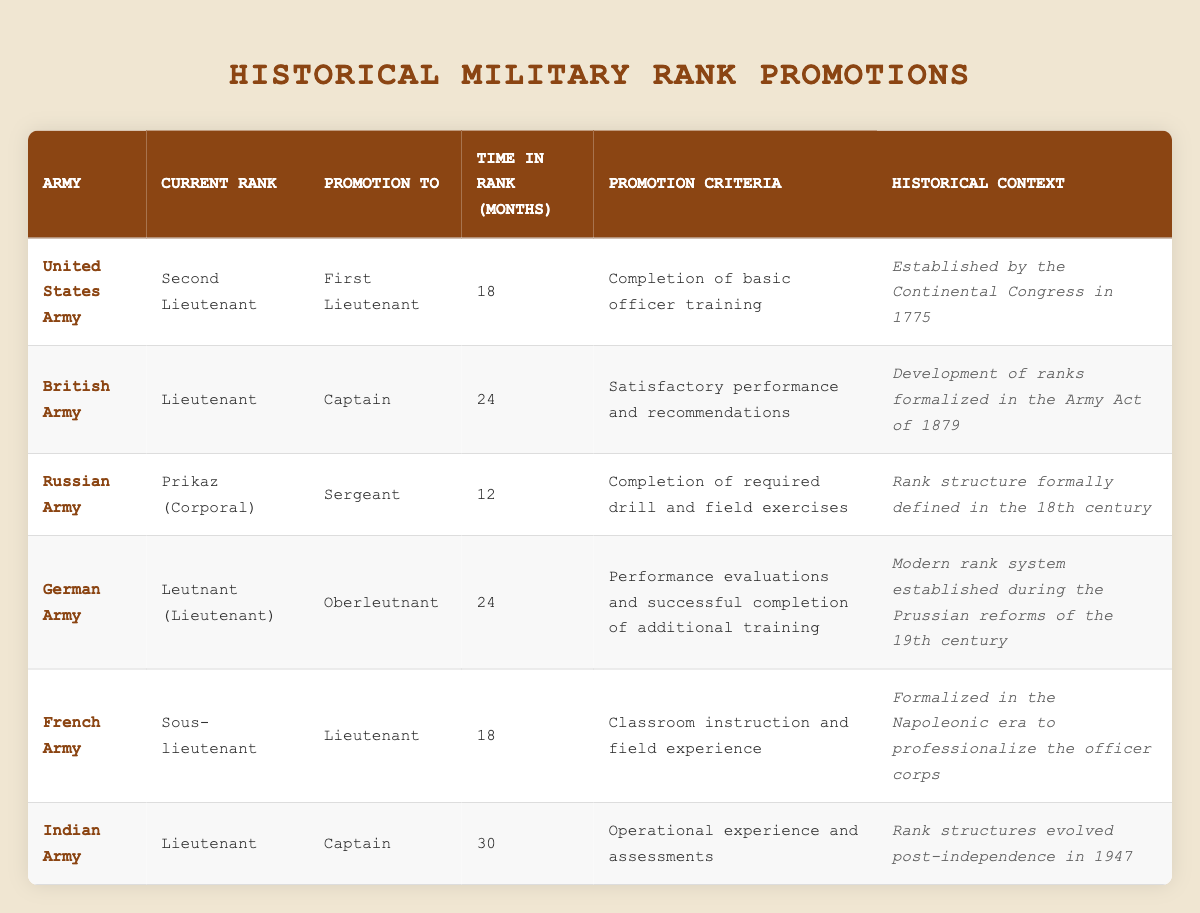What is the promotion rank from Second Lieutenant in the United States Army? According to the table, the promotion rank from Second Lieutenant in the United States Army is First Lieutenant.
Answer: First Lieutenant How long does it take to be promoted from Lieutenant to Captain in the British Army? The table shows that it takes 24 months to be promoted from Lieutenant to Captain in the British Army.
Answer: 24 months Is the promotion from Prikaz (Corporal) to Sergeant in the Russian Army based on completion of required drill? Yes, the promotion criteria for this rank are explicitly stated as the completion of required drill and field exercises in the table.
Answer: Yes What is the average time in rank required for promotions among all listed armies? To find the average time, add the time in rank for all armies: (18 + 24 + 12 + 24 + 18 + 30) = 126. There are six armies, so divide 126 by 6, resulting in an average time in rank of 21 months.
Answer: 21 months Which army has the longest time in rank for promotion to Captain? By examining the table, the Indian Army has the longest time in rank for promotion to Captain, which is 30 months, according to the given data.
Answer: Indian Army What is the historical context of the promotion from Sous-lieutenant to Lieutenant in the French Army? The historical context provided in the table states that this rank promotion was formalized in the Napoleonic era to professionalize the officer corps.
Answer: Formalized in the Napoleonic era How many ranks does the German Army require promotion from Leutnant to Oberleutnant? The table indicates that the German Army requires a promotion from Leutnant to Oberleutnant after 24 months based on performance evaluations and additional training.
Answer: 1 rank Are all promotions involving the rank Captain based on operational experience? No, the table shows that in the British Army, promotion to Captain is based on satisfactory performance and recommendations, not solely on operational experience.
Answer: No What is the promotion criteria for a Lieutenant to Captain in the Indian Army? The promotion criteria for a Lieutenant to Captain in the Indian Army is based on operational experience and assessments as listed in the table.
Answer: Operational experience and assessments 